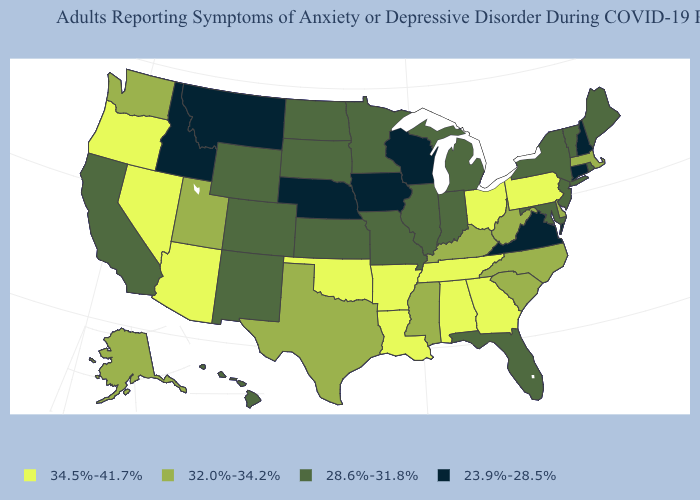What is the highest value in the USA?
Write a very short answer. 34.5%-41.7%. Which states hav the highest value in the MidWest?
Be succinct. Ohio. What is the value of New York?
Short answer required. 28.6%-31.8%. What is the value of New Hampshire?
Give a very brief answer. 23.9%-28.5%. What is the value of North Carolina?
Be succinct. 32.0%-34.2%. Does Wisconsin have the lowest value in the USA?
Quick response, please. Yes. Among the states that border Vermont , does Massachusetts have the lowest value?
Quick response, please. No. Does Idaho have the lowest value in the USA?
Keep it brief. Yes. Does Connecticut have a lower value than Montana?
Concise answer only. No. Which states have the lowest value in the West?
Keep it brief. Idaho, Montana. Name the states that have a value in the range 34.5%-41.7%?
Write a very short answer. Alabama, Arizona, Arkansas, Georgia, Louisiana, Nevada, Ohio, Oklahoma, Oregon, Pennsylvania, Tennessee. Does Arkansas have the highest value in the USA?
Write a very short answer. Yes. What is the highest value in the South ?
Keep it brief. 34.5%-41.7%. Name the states that have a value in the range 28.6%-31.8%?
Be succinct. California, Colorado, Florida, Hawaii, Illinois, Indiana, Kansas, Maine, Maryland, Michigan, Minnesota, Missouri, New Jersey, New Mexico, New York, North Dakota, Rhode Island, South Dakota, Vermont, Wyoming. 